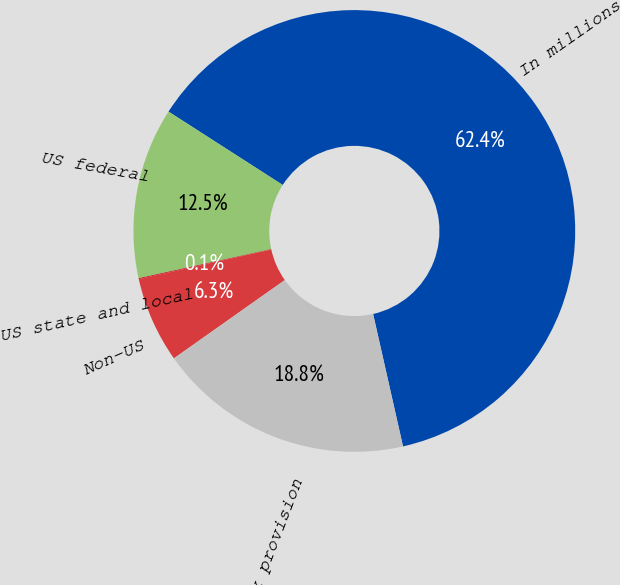<chart> <loc_0><loc_0><loc_500><loc_500><pie_chart><fcel>In millions<fcel>US federal<fcel>US state and local<fcel>Non-US<fcel>Income tax provision<nl><fcel>62.37%<fcel>12.52%<fcel>0.06%<fcel>6.29%<fcel>18.75%<nl></chart> 